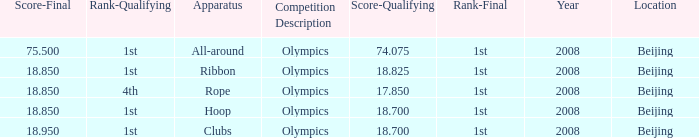What was her concluding score for the ribbon apparatus? 18.85. 